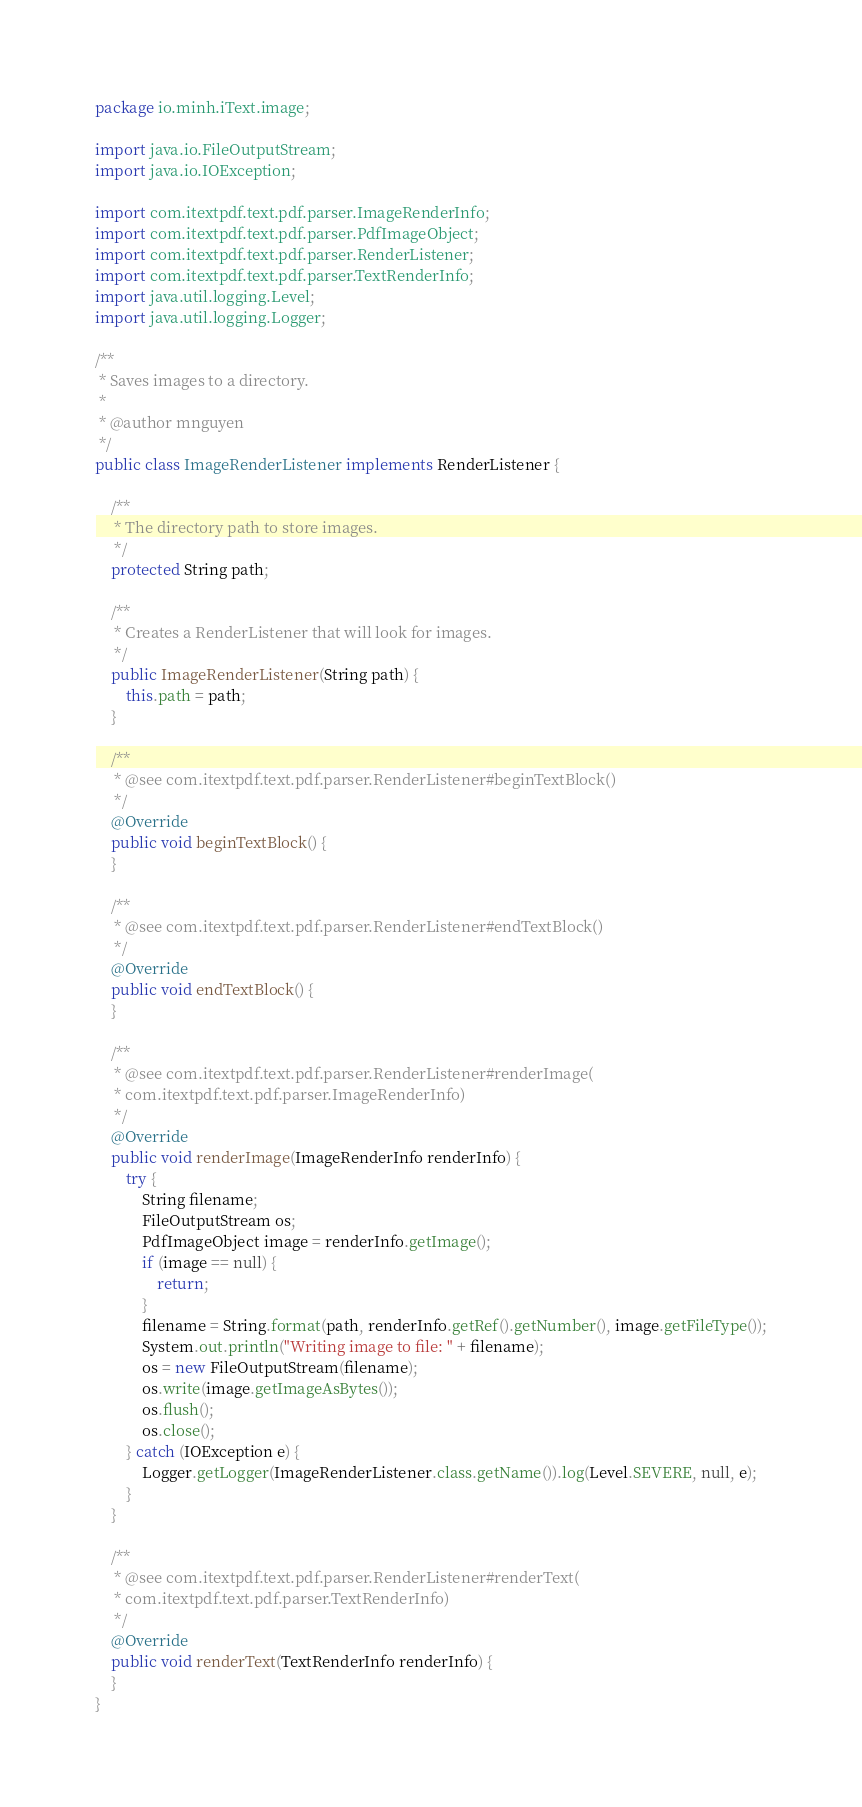<code> <loc_0><loc_0><loc_500><loc_500><_Java_>package io.minh.iText.image;

import java.io.FileOutputStream;
import java.io.IOException;

import com.itextpdf.text.pdf.parser.ImageRenderInfo;
import com.itextpdf.text.pdf.parser.PdfImageObject;
import com.itextpdf.text.pdf.parser.RenderListener;
import com.itextpdf.text.pdf.parser.TextRenderInfo;
import java.util.logging.Level;
import java.util.logging.Logger;

/**
 * Saves images to a directory.
 *
 * @author mnguyen
 */
public class ImageRenderListener implements RenderListener {

    /**
     * The directory path to store images.
     */
    protected String path;

    /**
     * Creates a RenderListener that will look for images.
     */
    public ImageRenderListener(String path) {
        this.path = path;
    }

    /**
     * @see com.itextpdf.text.pdf.parser.RenderListener#beginTextBlock()
     */
    @Override
    public void beginTextBlock() {
    }

    /**
     * @see com.itextpdf.text.pdf.parser.RenderListener#endTextBlock()
     */
    @Override
    public void endTextBlock() {
    }

    /**
     * @see com.itextpdf.text.pdf.parser.RenderListener#renderImage(
     * com.itextpdf.text.pdf.parser.ImageRenderInfo)
     */
    @Override
    public void renderImage(ImageRenderInfo renderInfo) {
        try {
            String filename;
            FileOutputStream os;
            PdfImageObject image = renderInfo.getImage();
            if (image == null) {
                return;
            }
            filename = String.format(path, renderInfo.getRef().getNumber(), image.getFileType());
            System.out.println("Writing image to file: " + filename);
            os = new FileOutputStream(filename);
            os.write(image.getImageAsBytes());
            os.flush();
            os.close();
        } catch (IOException e) {
            Logger.getLogger(ImageRenderListener.class.getName()).log(Level.SEVERE, null, e);
        }
    }

    /**
     * @see com.itextpdf.text.pdf.parser.RenderListener#renderText(
     * com.itextpdf.text.pdf.parser.TextRenderInfo)
     */
    @Override
    public void renderText(TextRenderInfo renderInfo) {
    }
}</code> 